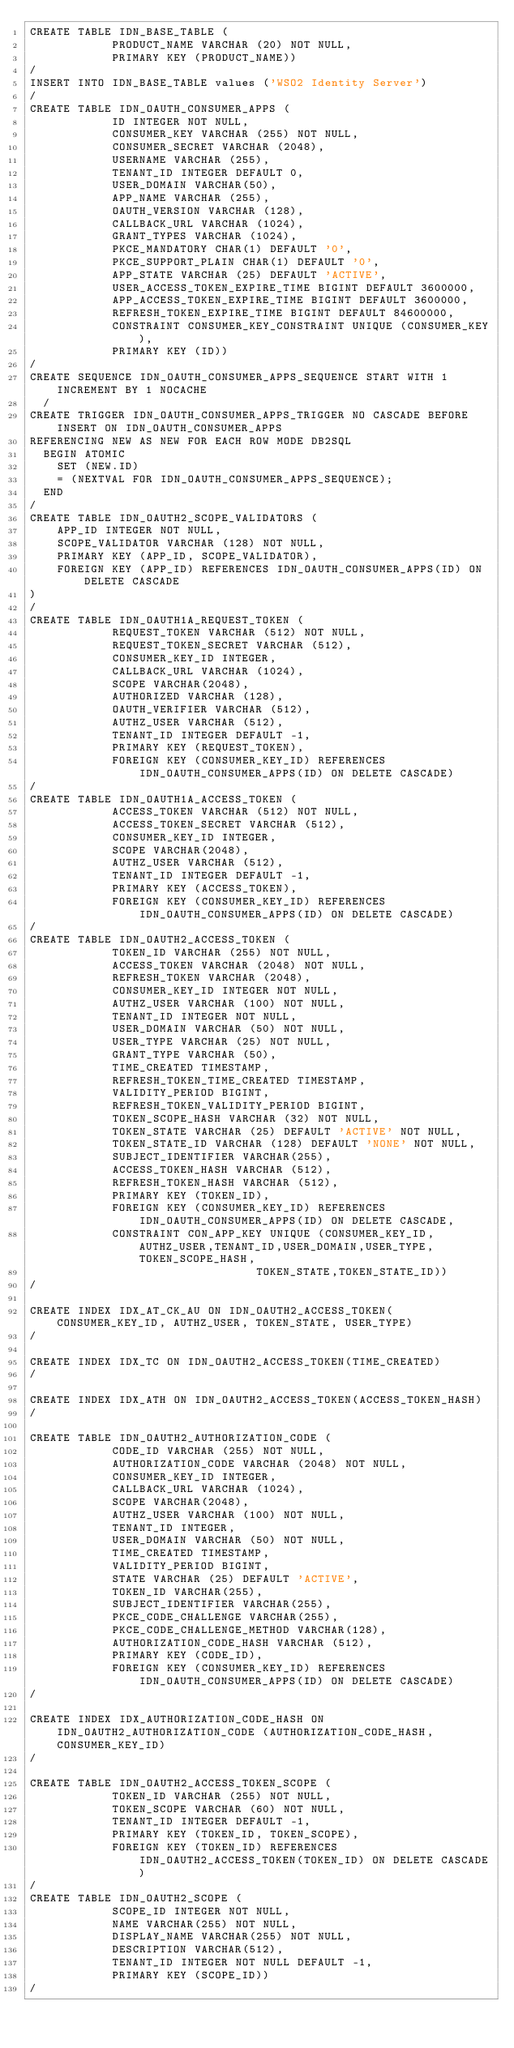<code> <loc_0><loc_0><loc_500><loc_500><_SQL_>CREATE TABLE IDN_BASE_TABLE (
            PRODUCT_NAME VARCHAR (20) NOT NULL,
            PRIMARY KEY (PRODUCT_NAME))
/
INSERT INTO IDN_BASE_TABLE values ('WSO2 Identity Server')
/
CREATE TABLE IDN_OAUTH_CONSUMER_APPS (
            ID INTEGER NOT NULL,
            CONSUMER_KEY VARCHAR (255) NOT NULL,
            CONSUMER_SECRET VARCHAR (2048),
            USERNAME VARCHAR (255),
            TENANT_ID INTEGER DEFAULT 0,
            USER_DOMAIN VARCHAR(50),
            APP_NAME VARCHAR (255),
            OAUTH_VERSION VARCHAR (128),
            CALLBACK_URL VARCHAR (1024),
            GRANT_TYPES VARCHAR (1024),
            PKCE_MANDATORY CHAR(1) DEFAULT '0',
            PKCE_SUPPORT_PLAIN CHAR(1) DEFAULT '0',
            APP_STATE VARCHAR (25) DEFAULT 'ACTIVE',
            USER_ACCESS_TOKEN_EXPIRE_TIME BIGINT DEFAULT 3600000,
            APP_ACCESS_TOKEN_EXPIRE_TIME BIGINT DEFAULT 3600000,
            REFRESH_TOKEN_EXPIRE_TIME BIGINT DEFAULT 84600000,
            CONSTRAINT CONSUMER_KEY_CONSTRAINT UNIQUE (CONSUMER_KEY),
            PRIMARY KEY (ID))
/
CREATE SEQUENCE IDN_OAUTH_CONSUMER_APPS_SEQUENCE START WITH 1 INCREMENT BY 1 NOCACHE
  /
CREATE TRIGGER IDN_OAUTH_CONSUMER_APPS_TRIGGER NO CASCADE BEFORE INSERT ON IDN_OAUTH_CONSUMER_APPS
REFERENCING NEW AS NEW FOR EACH ROW MODE DB2SQL
  BEGIN ATOMIC
    SET (NEW.ID)
    = (NEXTVAL FOR IDN_OAUTH_CONSUMER_APPS_SEQUENCE);
  END
/
CREATE TABLE IDN_OAUTH2_SCOPE_VALIDATORS (
	APP_ID INTEGER NOT NULL,
	SCOPE_VALIDATOR VARCHAR (128) NOT NULL,
	PRIMARY KEY (APP_ID, SCOPE_VALIDATOR),
	FOREIGN KEY (APP_ID) REFERENCES IDN_OAUTH_CONSUMER_APPS(ID) ON DELETE CASCADE
)
/
CREATE TABLE IDN_OAUTH1A_REQUEST_TOKEN (
            REQUEST_TOKEN VARCHAR (512) NOT NULL,
            REQUEST_TOKEN_SECRET VARCHAR (512),
            CONSUMER_KEY_ID INTEGER,
            CALLBACK_URL VARCHAR (1024),
            SCOPE VARCHAR(2048),
            AUTHORIZED VARCHAR (128),
            OAUTH_VERIFIER VARCHAR (512),
            AUTHZ_USER VARCHAR (512),
            TENANT_ID INTEGER DEFAULT -1,
            PRIMARY KEY (REQUEST_TOKEN),
            FOREIGN KEY (CONSUMER_KEY_ID) REFERENCES IDN_OAUTH_CONSUMER_APPS(ID) ON DELETE CASCADE)
/
CREATE TABLE IDN_OAUTH1A_ACCESS_TOKEN (
            ACCESS_TOKEN VARCHAR (512) NOT NULL,
            ACCESS_TOKEN_SECRET VARCHAR (512),
            CONSUMER_KEY_ID INTEGER,
            SCOPE VARCHAR(2048),
            AUTHZ_USER VARCHAR (512),
            TENANT_ID INTEGER DEFAULT -1,
            PRIMARY KEY (ACCESS_TOKEN),
            FOREIGN KEY (CONSUMER_KEY_ID) REFERENCES IDN_OAUTH_CONSUMER_APPS(ID) ON DELETE CASCADE)
/
CREATE TABLE IDN_OAUTH2_ACCESS_TOKEN (
            TOKEN_ID VARCHAR (255) NOT NULL,
            ACCESS_TOKEN VARCHAR (2048) NOT NULL,
            REFRESH_TOKEN VARCHAR (2048),
            CONSUMER_KEY_ID INTEGER NOT NULL,
            AUTHZ_USER VARCHAR (100) NOT NULL,
            TENANT_ID INTEGER NOT NULL,
            USER_DOMAIN VARCHAR (50) NOT NULL,
            USER_TYPE VARCHAR (25) NOT NULL,
            GRANT_TYPE VARCHAR (50),
            TIME_CREATED TIMESTAMP,
            REFRESH_TOKEN_TIME_CREATED TIMESTAMP,
            VALIDITY_PERIOD BIGINT,
            REFRESH_TOKEN_VALIDITY_PERIOD BIGINT,
            TOKEN_SCOPE_HASH VARCHAR (32) NOT NULL,
            TOKEN_STATE VARCHAR (25) DEFAULT 'ACTIVE' NOT NULL,
            TOKEN_STATE_ID VARCHAR (128) DEFAULT 'NONE' NOT NULL,
            SUBJECT_IDENTIFIER VARCHAR(255),
            ACCESS_TOKEN_HASH VARCHAR (512),
            REFRESH_TOKEN_HASH VARCHAR (512),
            PRIMARY KEY (TOKEN_ID),
            FOREIGN KEY (CONSUMER_KEY_ID) REFERENCES IDN_OAUTH_CONSUMER_APPS(ID) ON DELETE CASCADE,
            CONSTRAINT CON_APP_KEY UNIQUE (CONSUMER_KEY_ID,AUTHZ_USER,TENANT_ID,USER_DOMAIN,USER_TYPE,TOKEN_SCOPE_HASH,
                                 TOKEN_STATE,TOKEN_STATE_ID))
/

CREATE INDEX IDX_AT_CK_AU ON IDN_OAUTH2_ACCESS_TOKEN(CONSUMER_KEY_ID, AUTHZ_USER, TOKEN_STATE, USER_TYPE)
/

CREATE INDEX IDX_TC ON IDN_OAUTH2_ACCESS_TOKEN(TIME_CREATED)
/

CREATE INDEX IDX_ATH ON IDN_OAUTH2_ACCESS_TOKEN(ACCESS_TOKEN_HASH)
/

CREATE TABLE IDN_OAUTH2_AUTHORIZATION_CODE (
            CODE_ID VARCHAR (255) NOT NULL,
            AUTHORIZATION_CODE VARCHAR (2048) NOT NULL,
            CONSUMER_KEY_ID INTEGER,
            CALLBACK_URL VARCHAR (1024),
            SCOPE VARCHAR(2048),
            AUTHZ_USER VARCHAR (100) NOT NULL,
            TENANT_ID INTEGER,
            USER_DOMAIN VARCHAR (50) NOT NULL,
            TIME_CREATED TIMESTAMP,
            VALIDITY_PERIOD BIGINT,
            STATE VARCHAR (25) DEFAULT 'ACTIVE',
            TOKEN_ID VARCHAR(255),
            SUBJECT_IDENTIFIER VARCHAR(255),
            PKCE_CODE_CHALLENGE VARCHAR(255),
            PKCE_CODE_CHALLENGE_METHOD VARCHAR(128),
            AUTHORIZATION_CODE_HASH VARCHAR (512),
            PRIMARY KEY (CODE_ID),
            FOREIGN KEY (CONSUMER_KEY_ID) REFERENCES IDN_OAUTH_CONSUMER_APPS(ID) ON DELETE CASCADE)
/

CREATE INDEX IDX_AUTHORIZATION_CODE_HASH ON IDN_OAUTH2_AUTHORIZATION_CODE (AUTHORIZATION_CODE_HASH, CONSUMER_KEY_ID)
/

CREATE TABLE IDN_OAUTH2_ACCESS_TOKEN_SCOPE (
            TOKEN_ID VARCHAR (255) NOT NULL,
            TOKEN_SCOPE VARCHAR (60) NOT NULL,
            TENANT_ID INTEGER DEFAULT -1,
            PRIMARY KEY (TOKEN_ID, TOKEN_SCOPE),
            FOREIGN KEY (TOKEN_ID) REFERENCES IDN_OAUTH2_ACCESS_TOKEN(TOKEN_ID) ON DELETE CASCADE)
/
CREATE TABLE IDN_OAUTH2_SCOPE (
            SCOPE_ID INTEGER NOT NULL,
            NAME VARCHAR(255) NOT NULL,
            DISPLAY_NAME VARCHAR(255) NOT NULL,
            DESCRIPTION VARCHAR(512),
            TENANT_ID INTEGER NOT NULL DEFAULT -1,
            PRIMARY KEY (SCOPE_ID))
/</code> 